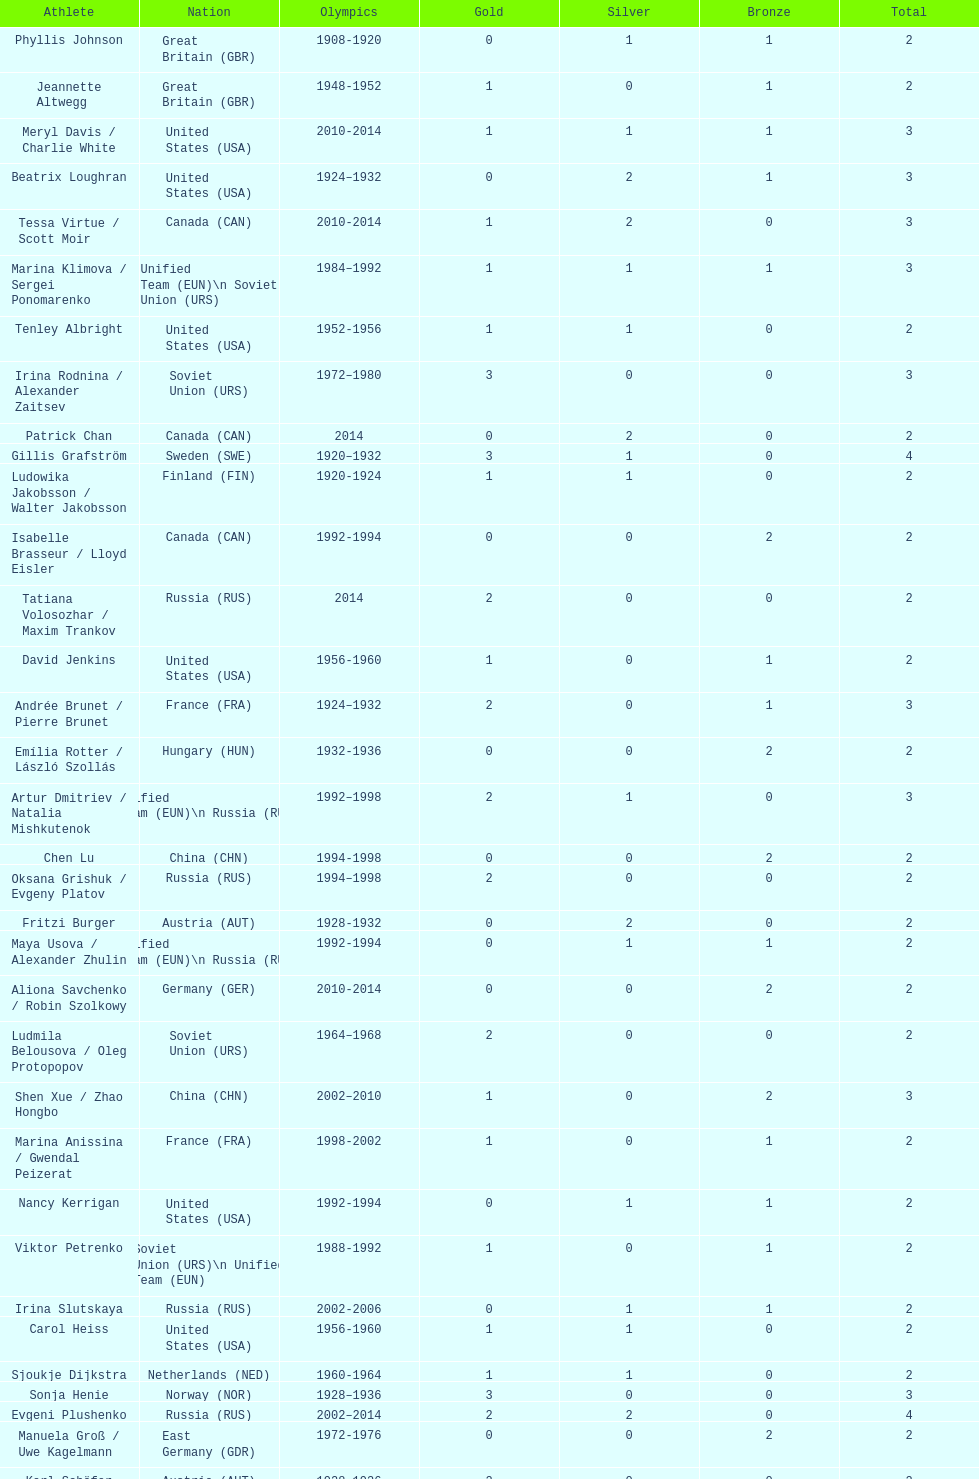How many medals have sweden and norway won combined? 7. 